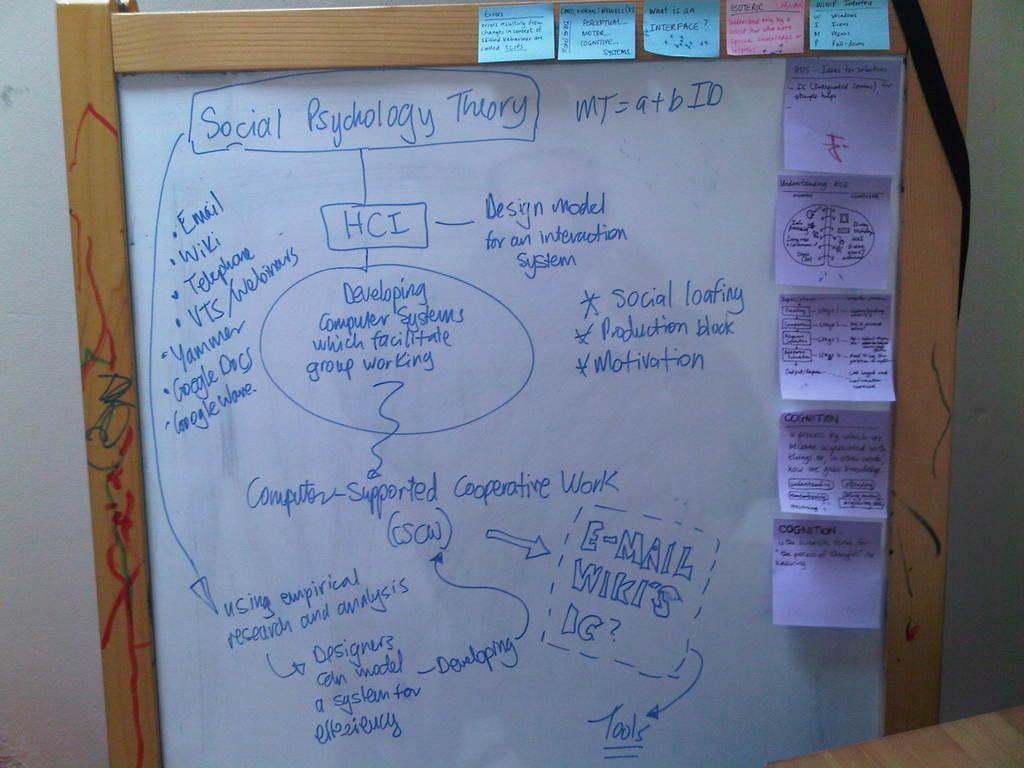Provide a one-sentence caption for the provided image. White board with sticky notes and Social Psychology Theory details. 